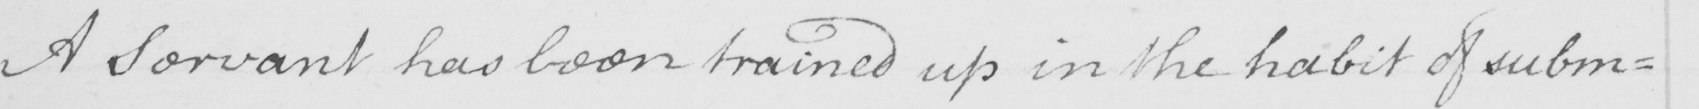Can you read and transcribe this handwriting? A servant has been trained up in the habit of subm= 